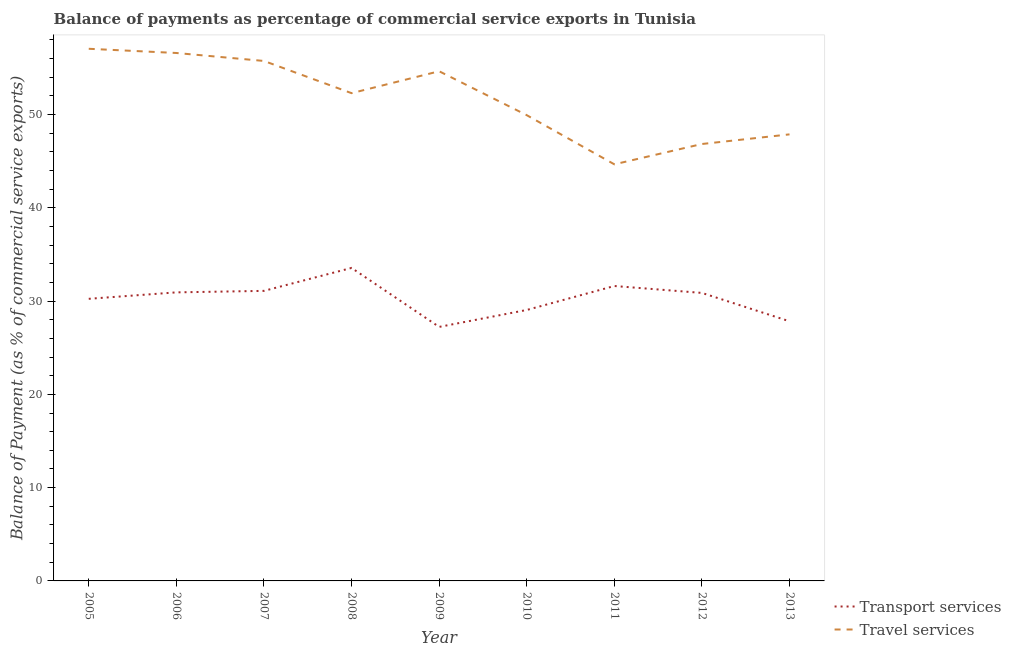How many different coloured lines are there?
Your answer should be very brief. 2. Is the number of lines equal to the number of legend labels?
Ensure brevity in your answer.  Yes. What is the balance of payments of travel services in 2005?
Your answer should be compact. 57.04. Across all years, what is the maximum balance of payments of travel services?
Ensure brevity in your answer.  57.04. Across all years, what is the minimum balance of payments of travel services?
Your response must be concise. 44.66. What is the total balance of payments of transport services in the graph?
Your response must be concise. 272.41. What is the difference between the balance of payments of transport services in 2011 and that in 2013?
Your answer should be very brief. 3.78. What is the difference between the balance of payments of travel services in 2007 and the balance of payments of transport services in 2009?
Provide a short and direct response. 28.51. What is the average balance of payments of travel services per year?
Ensure brevity in your answer.  51.73. In the year 2009, what is the difference between the balance of payments of transport services and balance of payments of travel services?
Keep it short and to the point. -27.41. In how many years, is the balance of payments of travel services greater than 40 %?
Make the answer very short. 9. What is the ratio of the balance of payments of transport services in 2011 to that in 2013?
Your response must be concise. 1.14. Is the balance of payments of transport services in 2005 less than that in 2006?
Provide a succinct answer. Yes. Is the difference between the balance of payments of transport services in 2008 and 2012 greater than the difference between the balance of payments of travel services in 2008 and 2012?
Provide a short and direct response. No. What is the difference between the highest and the second highest balance of payments of travel services?
Ensure brevity in your answer.  0.45. What is the difference between the highest and the lowest balance of payments of travel services?
Provide a short and direct response. 12.38. Is the sum of the balance of payments of transport services in 2010 and 2012 greater than the maximum balance of payments of travel services across all years?
Provide a short and direct response. Yes. Is the balance of payments of travel services strictly less than the balance of payments of transport services over the years?
Your answer should be compact. No. How many lines are there?
Make the answer very short. 2. How many years are there in the graph?
Your response must be concise. 9. What is the difference between two consecutive major ticks on the Y-axis?
Give a very brief answer. 10. Does the graph contain any zero values?
Provide a short and direct response. No. How are the legend labels stacked?
Offer a terse response. Vertical. What is the title of the graph?
Offer a very short reply. Balance of payments as percentage of commercial service exports in Tunisia. Does "Working capital" appear as one of the legend labels in the graph?
Your answer should be very brief. No. What is the label or title of the X-axis?
Offer a very short reply. Year. What is the label or title of the Y-axis?
Provide a short and direct response. Balance of Payment (as % of commercial service exports). What is the Balance of Payment (as % of commercial service exports) in Transport services in 2005?
Keep it short and to the point. 30.24. What is the Balance of Payment (as % of commercial service exports) in Travel services in 2005?
Your answer should be compact. 57.04. What is the Balance of Payment (as % of commercial service exports) in Transport services in 2006?
Make the answer very short. 30.93. What is the Balance of Payment (as % of commercial service exports) of Travel services in 2006?
Your response must be concise. 56.59. What is the Balance of Payment (as % of commercial service exports) of Transport services in 2007?
Give a very brief answer. 31.09. What is the Balance of Payment (as % of commercial service exports) of Travel services in 2007?
Provide a succinct answer. 55.74. What is the Balance of Payment (as % of commercial service exports) of Transport services in 2008?
Make the answer very short. 33.55. What is the Balance of Payment (as % of commercial service exports) of Travel services in 2008?
Keep it short and to the point. 52.29. What is the Balance of Payment (as % of commercial service exports) of Transport services in 2009?
Your answer should be compact. 27.23. What is the Balance of Payment (as % of commercial service exports) in Travel services in 2009?
Ensure brevity in your answer.  54.63. What is the Balance of Payment (as % of commercial service exports) in Transport services in 2010?
Give a very brief answer. 29.04. What is the Balance of Payment (as % of commercial service exports) of Travel services in 2010?
Keep it short and to the point. 49.93. What is the Balance of Payment (as % of commercial service exports) in Transport services in 2011?
Keep it short and to the point. 31.61. What is the Balance of Payment (as % of commercial service exports) in Travel services in 2011?
Your answer should be very brief. 44.66. What is the Balance of Payment (as % of commercial service exports) in Transport services in 2012?
Keep it short and to the point. 30.87. What is the Balance of Payment (as % of commercial service exports) in Travel services in 2012?
Ensure brevity in your answer.  46.84. What is the Balance of Payment (as % of commercial service exports) of Transport services in 2013?
Provide a short and direct response. 27.83. What is the Balance of Payment (as % of commercial service exports) of Travel services in 2013?
Offer a terse response. 47.87. Across all years, what is the maximum Balance of Payment (as % of commercial service exports) in Transport services?
Offer a terse response. 33.55. Across all years, what is the maximum Balance of Payment (as % of commercial service exports) in Travel services?
Offer a very short reply. 57.04. Across all years, what is the minimum Balance of Payment (as % of commercial service exports) of Transport services?
Offer a terse response. 27.23. Across all years, what is the minimum Balance of Payment (as % of commercial service exports) in Travel services?
Offer a terse response. 44.66. What is the total Balance of Payment (as % of commercial service exports) of Transport services in the graph?
Provide a short and direct response. 272.41. What is the total Balance of Payment (as % of commercial service exports) of Travel services in the graph?
Offer a terse response. 465.59. What is the difference between the Balance of Payment (as % of commercial service exports) of Transport services in 2005 and that in 2006?
Your answer should be compact. -0.69. What is the difference between the Balance of Payment (as % of commercial service exports) of Travel services in 2005 and that in 2006?
Your answer should be compact. 0.45. What is the difference between the Balance of Payment (as % of commercial service exports) in Transport services in 2005 and that in 2007?
Make the answer very short. -0.85. What is the difference between the Balance of Payment (as % of commercial service exports) in Travel services in 2005 and that in 2007?
Make the answer very short. 1.3. What is the difference between the Balance of Payment (as % of commercial service exports) in Transport services in 2005 and that in 2008?
Make the answer very short. -3.31. What is the difference between the Balance of Payment (as % of commercial service exports) of Travel services in 2005 and that in 2008?
Ensure brevity in your answer.  4.76. What is the difference between the Balance of Payment (as % of commercial service exports) in Transport services in 2005 and that in 2009?
Offer a terse response. 3.01. What is the difference between the Balance of Payment (as % of commercial service exports) in Travel services in 2005 and that in 2009?
Your response must be concise. 2.41. What is the difference between the Balance of Payment (as % of commercial service exports) in Transport services in 2005 and that in 2010?
Your answer should be very brief. 1.2. What is the difference between the Balance of Payment (as % of commercial service exports) in Travel services in 2005 and that in 2010?
Give a very brief answer. 7.12. What is the difference between the Balance of Payment (as % of commercial service exports) of Transport services in 2005 and that in 2011?
Make the answer very short. -1.37. What is the difference between the Balance of Payment (as % of commercial service exports) of Travel services in 2005 and that in 2011?
Make the answer very short. 12.38. What is the difference between the Balance of Payment (as % of commercial service exports) in Transport services in 2005 and that in 2012?
Provide a succinct answer. -0.63. What is the difference between the Balance of Payment (as % of commercial service exports) of Travel services in 2005 and that in 2012?
Give a very brief answer. 10.21. What is the difference between the Balance of Payment (as % of commercial service exports) of Transport services in 2005 and that in 2013?
Make the answer very short. 2.41. What is the difference between the Balance of Payment (as % of commercial service exports) of Travel services in 2005 and that in 2013?
Provide a short and direct response. 9.17. What is the difference between the Balance of Payment (as % of commercial service exports) in Transport services in 2006 and that in 2007?
Ensure brevity in your answer.  -0.16. What is the difference between the Balance of Payment (as % of commercial service exports) in Travel services in 2006 and that in 2007?
Give a very brief answer. 0.85. What is the difference between the Balance of Payment (as % of commercial service exports) in Transport services in 2006 and that in 2008?
Keep it short and to the point. -2.62. What is the difference between the Balance of Payment (as % of commercial service exports) in Travel services in 2006 and that in 2008?
Ensure brevity in your answer.  4.31. What is the difference between the Balance of Payment (as % of commercial service exports) of Transport services in 2006 and that in 2009?
Your answer should be very brief. 3.7. What is the difference between the Balance of Payment (as % of commercial service exports) in Travel services in 2006 and that in 2009?
Provide a short and direct response. 1.96. What is the difference between the Balance of Payment (as % of commercial service exports) in Transport services in 2006 and that in 2010?
Make the answer very short. 1.89. What is the difference between the Balance of Payment (as % of commercial service exports) in Travel services in 2006 and that in 2010?
Keep it short and to the point. 6.67. What is the difference between the Balance of Payment (as % of commercial service exports) of Transport services in 2006 and that in 2011?
Make the answer very short. -0.68. What is the difference between the Balance of Payment (as % of commercial service exports) of Travel services in 2006 and that in 2011?
Keep it short and to the point. 11.93. What is the difference between the Balance of Payment (as % of commercial service exports) in Transport services in 2006 and that in 2012?
Your response must be concise. 0.06. What is the difference between the Balance of Payment (as % of commercial service exports) in Travel services in 2006 and that in 2012?
Offer a terse response. 9.76. What is the difference between the Balance of Payment (as % of commercial service exports) in Transport services in 2006 and that in 2013?
Your response must be concise. 3.1. What is the difference between the Balance of Payment (as % of commercial service exports) in Travel services in 2006 and that in 2013?
Make the answer very short. 8.72. What is the difference between the Balance of Payment (as % of commercial service exports) of Transport services in 2007 and that in 2008?
Provide a short and direct response. -2.46. What is the difference between the Balance of Payment (as % of commercial service exports) of Travel services in 2007 and that in 2008?
Give a very brief answer. 3.45. What is the difference between the Balance of Payment (as % of commercial service exports) in Transport services in 2007 and that in 2009?
Offer a very short reply. 3.86. What is the difference between the Balance of Payment (as % of commercial service exports) in Travel services in 2007 and that in 2009?
Your answer should be compact. 1.1. What is the difference between the Balance of Payment (as % of commercial service exports) in Transport services in 2007 and that in 2010?
Make the answer very short. 2.05. What is the difference between the Balance of Payment (as % of commercial service exports) in Travel services in 2007 and that in 2010?
Provide a short and direct response. 5.81. What is the difference between the Balance of Payment (as % of commercial service exports) of Transport services in 2007 and that in 2011?
Offer a very short reply. -0.52. What is the difference between the Balance of Payment (as % of commercial service exports) in Travel services in 2007 and that in 2011?
Make the answer very short. 11.08. What is the difference between the Balance of Payment (as % of commercial service exports) in Transport services in 2007 and that in 2012?
Keep it short and to the point. 0.22. What is the difference between the Balance of Payment (as % of commercial service exports) of Travel services in 2007 and that in 2012?
Provide a short and direct response. 8.9. What is the difference between the Balance of Payment (as % of commercial service exports) in Transport services in 2007 and that in 2013?
Offer a very short reply. 3.26. What is the difference between the Balance of Payment (as % of commercial service exports) of Travel services in 2007 and that in 2013?
Provide a succinct answer. 7.87. What is the difference between the Balance of Payment (as % of commercial service exports) in Transport services in 2008 and that in 2009?
Offer a very short reply. 6.32. What is the difference between the Balance of Payment (as % of commercial service exports) in Travel services in 2008 and that in 2009?
Offer a very short reply. -2.35. What is the difference between the Balance of Payment (as % of commercial service exports) in Transport services in 2008 and that in 2010?
Give a very brief answer. 4.51. What is the difference between the Balance of Payment (as % of commercial service exports) of Travel services in 2008 and that in 2010?
Provide a succinct answer. 2.36. What is the difference between the Balance of Payment (as % of commercial service exports) of Transport services in 2008 and that in 2011?
Ensure brevity in your answer.  1.94. What is the difference between the Balance of Payment (as % of commercial service exports) in Travel services in 2008 and that in 2011?
Ensure brevity in your answer.  7.63. What is the difference between the Balance of Payment (as % of commercial service exports) in Transport services in 2008 and that in 2012?
Offer a very short reply. 2.68. What is the difference between the Balance of Payment (as % of commercial service exports) of Travel services in 2008 and that in 2012?
Give a very brief answer. 5.45. What is the difference between the Balance of Payment (as % of commercial service exports) of Transport services in 2008 and that in 2013?
Offer a terse response. 5.72. What is the difference between the Balance of Payment (as % of commercial service exports) in Travel services in 2008 and that in 2013?
Your response must be concise. 4.42. What is the difference between the Balance of Payment (as % of commercial service exports) in Transport services in 2009 and that in 2010?
Offer a terse response. -1.81. What is the difference between the Balance of Payment (as % of commercial service exports) of Travel services in 2009 and that in 2010?
Give a very brief answer. 4.71. What is the difference between the Balance of Payment (as % of commercial service exports) in Transport services in 2009 and that in 2011?
Give a very brief answer. -4.38. What is the difference between the Balance of Payment (as % of commercial service exports) of Travel services in 2009 and that in 2011?
Offer a very short reply. 9.98. What is the difference between the Balance of Payment (as % of commercial service exports) of Transport services in 2009 and that in 2012?
Ensure brevity in your answer.  -3.64. What is the difference between the Balance of Payment (as % of commercial service exports) in Travel services in 2009 and that in 2012?
Your response must be concise. 7.8. What is the difference between the Balance of Payment (as % of commercial service exports) in Transport services in 2009 and that in 2013?
Make the answer very short. -0.6. What is the difference between the Balance of Payment (as % of commercial service exports) of Travel services in 2009 and that in 2013?
Your response must be concise. 6.77. What is the difference between the Balance of Payment (as % of commercial service exports) of Transport services in 2010 and that in 2011?
Your answer should be very brief. -2.57. What is the difference between the Balance of Payment (as % of commercial service exports) of Travel services in 2010 and that in 2011?
Provide a short and direct response. 5.27. What is the difference between the Balance of Payment (as % of commercial service exports) in Transport services in 2010 and that in 2012?
Your answer should be compact. -1.83. What is the difference between the Balance of Payment (as % of commercial service exports) of Travel services in 2010 and that in 2012?
Give a very brief answer. 3.09. What is the difference between the Balance of Payment (as % of commercial service exports) of Transport services in 2010 and that in 2013?
Provide a succinct answer. 1.21. What is the difference between the Balance of Payment (as % of commercial service exports) of Travel services in 2010 and that in 2013?
Keep it short and to the point. 2.06. What is the difference between the Balance of Payment (as % of commercial service exports) in Transport services in 2011 and that in 2012?
Provide a short and direct response. 0.74. What is the difference between the Balance of Payment (as % of commercial service exports) in Travel services in 2011 and that in 2012?
Your answer should be very brief. -2.18. What is the difference between the Balance of Payment (as % of commercial service exports) in Transport services in 2011 and that in 2013?
Provide a short and direct response. 3.78. What is the difference between the Balance of Payment (as % of commercial service exports) in Travel services in 2011 and that in 2013?
Keep it short and to the point. -3.21. What is the difference between the Balance of Payment (as % of commercial service exports) of Transport services in 2012 and that in 2013?
Keep it short and to the point. 3.04. What is the difference between the Balance of Payment (as % of commercial service exports) of Travel services in 2012 and that in 2013?
Offer a very short reply. -1.03. What is the difference between the Balance of Payment (as % of commercial service exports) of Transport services in 2005 and the Balance of Payment (as % of commercial service exports) of Travel services in 2006?
Make the answer very short. -26.35. What is the difference between the Balance of Payment (as % of commercial service exports) in Transport services in 2005 and the Balance of Payment (as % of commercial service exports) in Travel services in 2007?
Offer a terse response. -25.5. What is the difference between the Balance of Payment (as % of commercial service exports) in Transport services in 2005 and the Balance of Payment (as % of commercial service exports) in Travel services in 2008?
Keep it short and to the point. -22.04. What is the difference between the Balance of Payment (as % of commercial service exports) in Transport services in 2005 and the Balance of Payment (as % of commercial service exports) in Travel services in 2009?
Provide a short and direct response. -24.39. What is the difference between the Balance of Payment (as % of commercial service exports) in Transport services in 2005 and the Balance of Payment (as % of commercial service exports) in Travel services in 2010?
Keep it short and to the point. -19.69. What is the difference between the Balance of Payment (as % of commercial service exports) in Transport services in 2005 and the Balance of Payment (as % of commercial service exports) in Travel services in 2011?
Give a very brief answer. -14.42. What is the difference between the Balance of Payment (as % of commercial service exports) in Transport services in 2005 and the Balance of Payment (as % of commercial service exports) in Travel services in 2012?
Keep it short and to the point. -16.59. What is the difference between the Balance of Payment (as % of commercial service exports) in Transport services in 2005 and the Balance of Payment (as % of commercial service exports) in Travel services in 2013?
Give a very brief answer. -17.63. What is the difference between the Balance of Payment (as % of commercial service exports) of Transport services in 2006 and the Balance of Payment (as % of commercial service exports) of Travel services in 2007?
Offer a very short reply. -24.81. What is the difference between the Balance of Payment (as % of commercial service exports) in Transport services in 2006 and the Balance of Payment (as % of commercial service exports) in Travel services in 2008?
Keep it short and to the point. -21.35. What is the difference between the Balance of Payment (as % of commercial service exports) of Transport services in 2006 and the Balance of Payment (as % of commercial service exports) of Travel services in 2009?
Your answer should be compact. -23.7. What is the difference between the Balance of Payment (as % of commercial service exports) in Transport services in 2006 and the Balance of Payment (as % of commercial service exports) in Travel services in 2010?
Your response must be concise. -18.99. What is the difference between the Balance of Payment (as % of commercial service exports) in Transport services in 2006 and the Balance of Payment (as % of commercial service exports) in Travel services in 2011?
Offer a very short reply. -13.73. What is the difference between the Balance of Payment (as % of commercial service exports) in Transport services in 2006 and the Balance of Payment (as % of commercial service exports) in Travel services in 2012?
Your answer should be very brief. -15.9. What is the difference between the Balance of Payment (as % of commercial service exports) of Transport services in 2006 and the Balance of Payment (as % of commercial service exports) of Travel services in 2013?
Your answer should be compact. -16.94. What is the difference between the Balance of Payment (as % of commercial service exports) in Transport services in 2007 and the Balance of Payment (as % of commercial service exports) in Travel services in 2008?
Give a very brief answer. -21.19. What is the difference between the Balance of Payment (as % of commercial service exports) of Transport services in 2007 and the Balance of Payment (as % of commercial service exports) of Travel services in 2009?
Ensure brevity in your answer.  -23.54. What is the difference between the Balance of Payment (as % of commercial service exports) of Transport services in 2007 and the Balance of Payment (as % of commercial service exports) of Travel services in 2010?
Your answer should be very brief. -18.83. What is the difference between the Balance of Payment (as % of commercial service exports) of Transport services in 2007 and the Balance of Payment (as % of commercial service exports) of Travel services in 2011?
Give a very brief answer. -13.57. What is the difference between the Balance of Payment (as % of commercial service exports) of Transport services in 2007 and the Balance of Payment (as % of commercial service exports) of Travel services in 2012?
Give a very brief answer. -15.74. What is the difference between the Balance of Payment (as % of commercial service exports) of Transport services in 2007 and the Balance of Payment (as % of commercial service exports) of Travel services in 2013?
Your answer should be very brief. -16.78. What is the difference between the Balance of Payment (as % of commercial service exports) of Transport services in 2008 and the Balance of Payment (as % of commercial service exports) of Travel services in 2009?
Ensure brevity in your answer.  -21.08. What is the difference between the Balance of Payment (as % of commercial service exports) of Transport services in 2008 and the Balance of Payment (as % of commercial service exports) of Travel services in 2010?
Offer a very short reply. -16.37. What is the difference between the Balance of Payment (as % of commercial service exports) of Transport services in 2008 and the Balance of Payment (as % of commercial service exports) of Travel services in 2011?
Your answer should be very brief. -11.11. What is the difference between the Balance of Payment (as % of commercial service exports) in Transport services in 2008 and the Balance of Payment (as % of commercial service exports) in Travel services in 2012?
Provide a succinct answer. -13.28. What is the difference between the Balance of Payment (as % of commercial service exports) in Transport services in 2008 and the Balance of Payment (as % of commercial service exports) in Travel services in 2013?
Your response must be concise. -14.32. What is the difference between the Balance of Payment (as % of commercial service exports) of Transport services in 2009 and the Balance of Payment (as % of commercial service exports) of Travel services in 2010?
Provide a short and direct response. -22.7. What is the difference between the Balance of Payment (as % of commercial service exports) of Transport services in 2009 and the Balance of Payment (as % of commercial service exports) of Travel services in 2011?
Provide a succinct answer. -17.43. What is the difference between the Balance of Payment (as % of commercial service exports) in Transport services in 2009 and the Balance of Payment (as % of commercial service exports) in Travel services in 2012?
Ensure brevity in your answer.  -19.61. What is the difference between the Balance of Payment (as % of commercial service exports) of Transport services in 2009 and the Balance of Payment (as % of commercial service exports) of Travel services in 2013?
Provide a succinct answer. -20.64. What is the difference between the Balance of Payment (as % of commercial service exports) in Transport services in 2010 and the Balance of Payment (as % of commercial service exports) in Travel services in 2011?
Offer a very short reply. -15.62. What is the difference between the Balance of Payment (as % of commercial service exports) of Transport services in 2010 and the Balance of Payment (as % of commercial service exports) of Travel services in 2012?
Your answer should be very brief. -17.79. What is the difference between the Balance of Payment (as % of commercial service exports) of Transport services in 2010 and the Balance of Payment (as % of commercial service exports) of Travel services in 2013?
Provide a short and direct response. -18.83. What is the difference between the Balance of Payment (as % of commercial service exports) in Transport services in 2011 and the Balance of Payment (as % of commercial service exports) in Travel services in 2012?
Provide a short and direct response. -15.22. What is the difference between the Balance of Payment (as % of commercial service exports) of Transport services in 2011 and the Balance of Payment (as % of commercial service exports) of Travel services in 2013?
Give a very brief answer. -16.26. What is the difference between the Balance of Payment (as % of commercial service exports) of Transport services in 2012 and the Balance of Payment (as % of commercial service exports) of Travel services in 2013?
Keep it short and to the point. -17. What is the average Balance of Payment (as % of commercial service exports) in Transport services per year?
Your response must be concise. 30.27. What is the average Balance of Payment (as % of commercial service exports) in Travel services per year?
Your answer should be very brief. 51.73. In the year 2005, what is the difference between the Balance of Payment (as % of commercial service exports) in Transport services and Balance of Payment (as % of commercial service exports) in Travel services?
Your answer should be compact. -26.8. In the year 2006, what is the difference between the Balance of Payment (as % of commercial service exports) of Transport services and Balance of Payment (as % of commercial service exports) of Travel services?
Make the answer very short. -25.66. In the year 2007, what is the difference between the Balance of Payment (as % of commercial service exports) of Transport services and Balance of Payment (as % of commercial service exports) of Travel services?
Provide a short and direct response. -24.65. In the year 2008, what is the difference between the Balance of Payment (as % of commercial service exports) in Transport services and Balance of Payment (as % of commercial service exports) in Travel services?
Provide a succinct answer. -18.73. In the year 2009, what is the difference between the Balance of Payment (as % of commercial service exports) in Transport services and Balance of Payment (as % of commercial service exports) in Travel services?
Your answer should be very brief. -27.41. In the year 2010, what is the difference between the Balance of Payment (as % of commercial service exports) in Transport services and Balance of Payment (as % of commercial service exports) in Travel services?
Provide a short and direct response. -20.88. In the year 2011, what is the difference between the Balance of Payment (as % of commercial service exports) in Transport services and Balance of Payment (as % of commercial service exports) in Travel services?
Your response must be concise. -13.05. In the year 2012, what is the difference between the Balance of Payment (as % of commercial service exports) in Transport services and Balance of Payment (as % of commercial service exports) in Travel services?
Provide a succinct answer. -15.96. In the year 2013, what is the difference between the Balance of Payment (as % of commercial service exports) of Transport services and Balance of Payment (as % of commercial service exports) of Travel services?
Offer a terse response. -20.04. What is the ratio of the Balance of Payment (as % of commercial service exports) in Transport services in 2005 to that in 2006?
Provide a short and direct response. 0.98. What is the ratio of the Balance of Payment (as % of commercial service exports) of Travel services in 2005 to that in 2006?
Provide a short and direct response. 1.01. What is the ratio of the Balance of Payment (as % of commercial service exports) of Transport services in 2005 to that in 2007?
Keep it short and to the point. 0.97. What is the ratio of the Balance of Payment (as % of commercial service exports) of Travel services in 2005 to that in 2007?
Your response must be concise. 1.02. What is the ratio of the Balance of Payment (as % of commercial service exports) of Transport services in 2005 to that in 2008?
Provide a short and direct response. 0.9. What is the ratio of the Balance of Payment (as % of commercial service exports) in Travel services in 2005 to that in 2008?
Keep it short and to the point. 1.09. What is the ratio of the Balance of Payment (as % of commercial service exports) in Transport services in 2005 to that in 2009?
Offer a very short reply. 1.11. What is the ratio of the Balance of Payment (as % of commercial service exports) in Travel services in 2005 to that in 2009?
Your answer should be compact. 1.04. What is the ratio of the Balance of Payment (as % of commercial service exports) in Transport services in 2005 to that in 2010?
Offer a very short reply. 1.04. What is the ratio of the Balance of Payment (as % of commercial service exports) of Travel services in 2005 to that in 2010?
Offer a very short reply. 1.14. What is the ratio of the Balance of Payment (as % of commercial service exports) of Transport services in 2005 to that in 2011?
Provide a short and direct response. 0.96. What is the ratio of the Balance of Payment (as % of commercial service exports) of Travel services in 2005 to that in 2011?
Provide a succinct answer. 1.28. What is the ratio of the Balance of Payment (as % of commercial service exports) in Transport services in 2005 to that in 2012?
Your response must be concise. 0.98. What is the ratio of the Balance of Payment (as % of commercial service exports) of Travel services in 2005 to that in 2012?
Make the answer very short. 1.22. What is the ratio of the Balance of Payment (as % of commercial service exports) in Transport services in 2005 to that in 2013?
Make the answer very short. 1.09. What is the ratio of the Balance of Payment (as % of commercial service exports) of Travel services in 2005 to that in 2013?
Your answer should be very brief. 1.19. What is the ratio of the Balance of Payment (as % of commercial service exports) in Travel services in 2006 to that in 2007?
Provide a succinct answer. 1.02. What is the ratio of the Balance of Payment (as % of commercial service exports) in Transport services in 2006 to that in 2008?
Provide a succinct answer. 0.92. What is the ratio of the Balance of Payment (as % of commercial service exports) in Travel services in 2006 to that in 2008?
Give a very brief answer. 1.08. What is the ratio of the Balance of Payment (as % of commercial service exports) of Transport services in 2006 to that in 2009?
Your answer should be very brief. 1.14. What is the ratio of the Balance of Payment (as % of commercial service exports) of Travel services in 2006 to that in 2009?
Offer a terse response. 1.04. What is the ratio of the Balance of Payment (as % of commercial service exports) in Transport services in 2006 to that in 2010?
Keep it short and to the point. 1.06. What is the ratio of the Balance of Payment (as % of commercial service exports) of Travel services in 2006 to that in 2010?
Offer a very short reply. 1.13. What is the ratio of the Balance of Payment (as % of commercial service exports) of Transport services in 2006 to that in 2011?
Keep it short and to the point. 0.98. What is the ratio of the Balance of Payment (as % of commercial service exports) of Travel services in 2006 to that in 2011?
Provide a short and direct response. 1.27. What is the ratio of the Balance of Payment (as % of commercial service exports) in Transport services in 2006 to that in 2012?
Provide a short and direct response. 1. What is the ratio of the Balance of Payment (as % of commercial service exports) of Travel services in 2006 to that in 2012?
Provide a succinct answer. 1.21. What is the ratio of the Balance of Payment (as % of commercial service exports) in Transport services in 2006 to that in 2013?
Provide a short and direct response. 1.11. What is the ratio of the Balance of Payment (as % of commercial service exports) of Travel services in 2006 to that in 2013?
Provide a succinct answer. 1.18. What is the ratio of the Balance of Payment (as % of commercial service exports) of Transport services in 2007 to that in 2008?
Make the answer very short. 0.93. What is the ratio of the Balance of Payment (as % of commercial service exports) of Travel services in 2007 to that in 2008?
Your answer should be very brief. 1.07. What is the ratio of the Balance of Payment (as % of commercial service exports) of Transport services in 2007 to that in 2009?
Your answer should be compact. 1.14. What is the ratio of the Balance of Payment (as % of commercial service exports) of Travel services in 2007 to that in 2009?
Make the answer very short. 1.02. What is the ratio of the Balance of Payment (as % of commercial service exports) of Transport services in 2007 to that in 2010?
Provide a short and direct response. 1.07. What is the ratio of the Balance of Payment (as % of commercial service exports) in Travel services in 2007 to that in 2010?
Offer a terse response. 1.12. What is the ratio of the Balance of Payment (as % of commercial service exports) of Transport services in 2007 to that in 2011?
Provide a short and direct response. 0.98. What is the ratio of the Balance of Payment (as % of commercial service exports) in Travel services in 2007 to that in 2011?
Your response must be concise. 1.25. What is the ratio of the Balance of Payment (as % of commercial service exports) in Transport services in 2007 to that in 2012?
Your answer should be compact. 1.01. What is the ratio of the Balance of Payment (as % of commercial service exports) of Travel services in 2007 to that in 2012?
Your answer should be compact. 1.19. What is the ratio of the Balance of Payment (as % of commercial service exports) of Transport services in 2007 to that in 2013?
Your answer should be very brief. 1.12. What is the ratio of the Balance of Payment (as % of commercial service exports) of Travel services in 2007 to that in 2013?
Your response must be concise. 1.16. What is the ratio of the Balance of Payment (as % of commercial service exports) of Transport services in 2008 to that in 2009?
Make the answer very short. 1.23. What is the ratio of the Balance of Payment (as % of commercial service exports) of Travel services in 2008 to that in 2009?
Your response must be concise. 0.96. What is the ratio of the Balance of Payment (as % of commercial service exports) in Transport services in 2008 to that in 2010?
Your answer should be very brief. 1.16. What is the ratio of the Balance of Payment (as % of commercial service exports) in Travel services in 2008 to that in 2010?
Keep it short and to the point. 1.05. What is the ratio of the Balance of Payment (as % of commercial service exports) of Transport services in 2008 to that in 2011?
Offer a very short reply. 1.06. What is the ratio of the Balance of Payment (as % of commercial service exports) in Travel services in 2008 to that in 2011?
Give a very brief answer. 1.17. What is the ratio of the Balance of Payment (as % of commercial service exports) of Transport services in 2008 to that in 2012?
Provide a succinct answer. 1.09. What is the ratio of the Balance of Payment (as % of commercial service exports) of Travel services in 2008 to that in 2012?
Provide a short and direct response. 1.12. What is the ratio of the Balance of Payment (as % of commercial service exports) of Transport services in 2008 to that in 2013?
Your answer should be very brief. 1.21. What is the ratio of the Balance of Payment (as % of commercial service exports) in Travel services in 2008 to that in 2013?
Your answer should be very brief. 1.09. What is the ratio of the Balance of Payment (as % of commercial service exports) in Transport services in 2009 to that in 2010?
Offer a very short reply. 0.94. What is the ratio of the Balance of Payment (as % of commercial service exports) of Travel services in 2009 to that in 2010?
Provide a succinct answer. 1.09. What is the ratio of the Balance of Payment (as % of commercial service exports) in Transport services in 2009 to that in 2011?
Make the answer very short. 0.86. What is the ratio of the Balance of Payment (as % of commercial service exports) of Travel services in 2009 to that in 2011?
Your answer should be very brief. 1.22. What is the ratio of the Balance of Payment (as % of commercial service exports) in Transport services in 2009 to that in 2012?
Your answer should be very brief. 0.88. What is the ratio of the Balance of Payment (as % of commercial service exports) in Travel services in 2009 to that in 2012?
Provide a succinct answer. 1.17. What is the ratio of the Balance of Payment (as % of commercial service exports) in Transport services in 2009 to that in 2013?
Your response must be concise. 0.98. What is the ratio of the Balance of Payment (as % of commercial service exports) of Travel services in 2009 to that in 2013?
Keep it short and to the point. 1.14. What is the ratio of the Balance of Payment (as % of commercial service exports) of Transport services in 2010 to that in 2011?
Offer a very short reply. 0.92. What is the ratio of the Balance of Payment (as % of commercial service exports) in Travel services in 2010 to that in 2011?
Your answer should be very brief. 1.12. What is the ratio of the Balance of Payment (as % of commercial service exports) of Transport services in 2010 to that in 2012?
Make the answer very short. 0.94. What is the ratio of the Balance of Payment (as % of commercial service exports) of Travel services in 2010 to that in 2012?
Provide a short and direct response. 1.07. What is the ratio of the Balance of Payment (as % of commercial service exports) in Transport services in 2010 to that in 2013?
Your answer should be compact. 1.04. What is the ratio of the Balance of Payment (as % of commercial service exports) of Travel services in 2010 to that in 2013?
Make the answer very short. 1.04. What is the ratio of the Balance of Payment (as % of commercial service exports) in Travel services in 2011 to that in 2012?
Offer a terse response. 0.95. What is the ratio of the Balance of Payment (as % of commercial service exports) of Transport services in 2011 to that in 2013?
Make the answer very short. 1.14. What is the ratio of the Balance of Payment (as % of commercial service exports) in Travel services in 2011 to that in 2013?
Keep it short and to the point. 0.93. What is the ratio of the Balance of Payment (as % of commercial service exports) in Transport services in 2012 to that in 2013?
Your response must be concise. 1.11. What is the ratio of the Balance of Payment (as % of commercial service exports) of Travel services in 2012 to that in 2013?
Your answer should be very brief. 0.98. What is the difference between the highest and the second highest Balance of Payment (as % of commercial service exports) of Transport services?
Give a very brief answer. 1.94. What is the difference between the highest and the second highest Balance of Payment (as % of commercial service exports) of Travel services?
Your response must be concise. 0.45. What is the difference between the highest and the lowest Balance of Payment (as % of commercial service exports) of Transport services?
Keep it short and to the point. 6.32. What is the difference between the highest and the lowest Balance of Payment (as % of commercial service exports) of Travel services?
Offer a terse response. 12.38. 